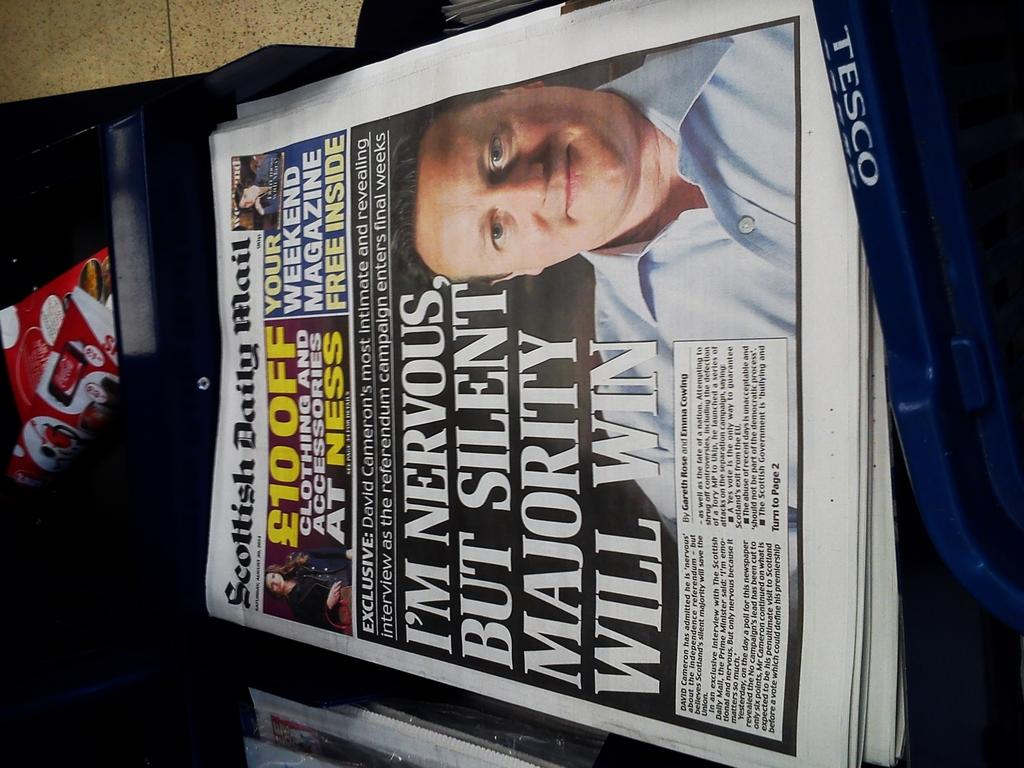What is present on the papers in the image? The provided facts do not specify any details about the papers, so we cannot determine what is present on them. Can you describe the objects in the image? The provided facts only mention that there are some objects in the image, but they do not specify what those objects are. What can be seen in the background of the image? The floor is visible in the background of the image. How many geese are visible on the papers in the image? There are no geese present in the image, as the provided facts only mention papers and objects without specifying any animals or birds. 